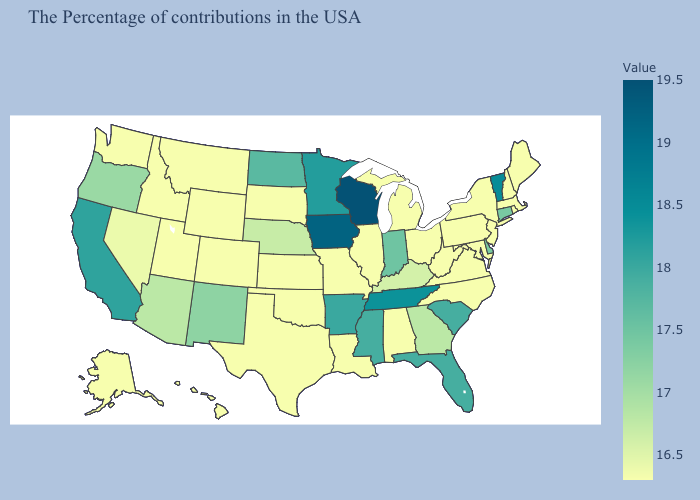Does the map have missing data?
Answer briefly. No. Does Wisconsin have the highest value in the USA?
Give a very brief answer. Yes. Does Texas have the lowest value in the South?
Keep it brief. Yes. Does Vermont have the highest value in the Northeast?
Quick response, please. Yes. Among the states that border Pennsylvania , which have the highest value?
Keep it brief. Delaware. Does Hawaii have a lower value than Minnesota?
Short answer required. Yes. 